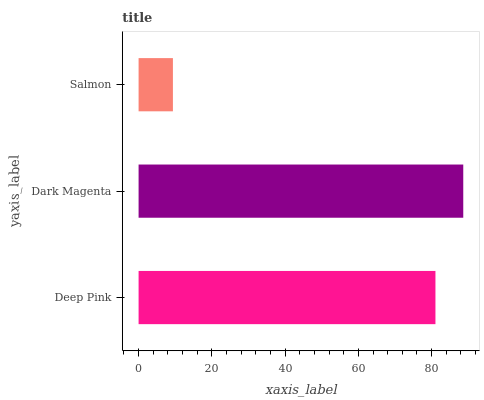Is Salmon the minimum?
Answer yes or no. Yes. Is Dark Magenta the maximum?
Answer yes or no. Yes. Is Dark Magenta the minimum?
Answer yes or no. No. Is Salmon the maximum?
Answer yes or no. No. Is Dark Magenta greater than Salmon?
Answer yes or no. Yes. Is Salmon less than Dark Magenta?
Answer yes or no. Yes. Is Salmon greater than Dark Magenta?
Answer yes or no. No. Is Dark Magenta less than Salmon?
Answer yes or no. No. Is Deep Pink the high median?
Answer yes or no. Yes. Is Deep Pink the low median?
Answer yes or no. Yes. Is Dark Magenta the high median?
Answer yes or no. No. Is Dark Magenta the low median?
Answer yes or no. No. 